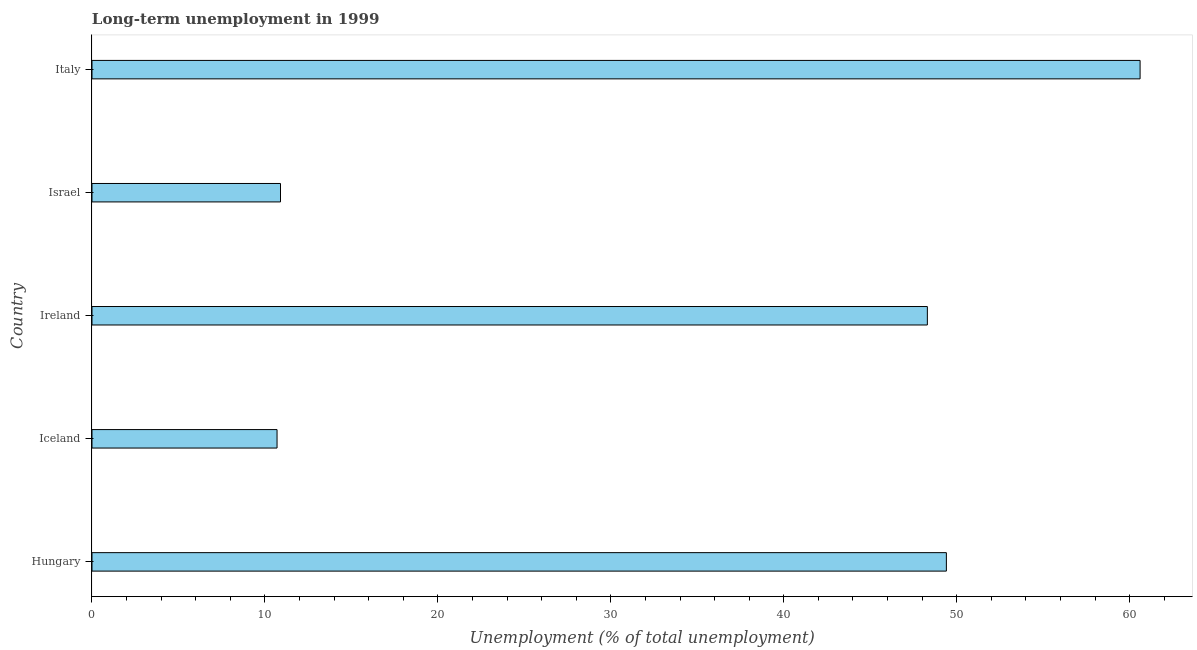Does the graph contain any zero values?
Offer a very short reply. No. Does the graph contain grids?
Keep it short and to the point. No. What is the title of the graph?
Your answer should be very brief. Long-term unemployment in 1999. What is the label or title of the X-axis?
Offer a terse response. Unemployment (% of total unemployment). What is the label or title of the Y-axis?
Make the answer very short. Country. What is the long-term unemployment in Italy?
Ensure brevity in your answer.  60.6. Across all countries, what is the maximum long-term unemployment?
Make the answer very short. 60.6. Across all countries, what is the minimum long-term unemployment?
Offer a very short reply. 10.7. In which country was the long-term unemployment maximum?
Your answer should be very brief. Italy. In which country was the long-term unemployment minimum?
Your response must be concise. Iceland. What is the sum of the long-term unemployment?
Your response must be concise. 179.9. What is the difference between the long-term unemployment in Hungary and Ireland?
Offer a very short reply. 1.1. What is the average long-term unemployment per country?
Make the answer very short. 35.98. What is the median long-term unemployment?
Offer a terse response. 48.3. Is the long-term unemployment in Iceland less than that in Ireland?
Your answer should be compact. Yes. Is the difference between the long-term unemployment in Iceland and Israel greater than the difference between any two countries?
Your answer should be very brief. No. Is the sum of the long-term unemployment in Iceland and Israel greater than the maximum long-term unemployment across all countries?
Keep it short and to the point. No. What is the difference between the highest and the lowest long-term unemployment?
Make the answer very short. 49.9. In how many countries, is the long-term unemployment greater than the average long-term unemployment taken over all countries?
Make the answer very short. 3. How many bars are there?
Give a very brief answer. 5. Are all the bars in the graph horizontal?
Your answer should be compact. Yes. How many countries are there in the graph?
Your response must be concise. 5. Are the values on the major ticks of X-axis written in scientific E-notation?
Provide a short and direct response. No. What is the Unemployment (% of total unemployment) in Hungary?
Make the answer very short. 49.4. What is the Unemployment (% of total unemployment) of Iceland?
Your answer should be very brief. 10.7. What is the Unemployment (% of total unemployment) in Ireland?
Provide a short and direct response. 48.3. What is the Unemployment (% of total unemployment) of Israel?
Ensure brevity in your answer.  10.9. What is the Unemployment (% of total unemployment) in Italy?
Keep it short and to the point. 60.6. What is the difference between the Unemployment (% of total unemployment) in Hungary and Iceland?
Offer a very short reply. 38.7. What is the difference between the Unemployment (% of total unemployment) in Hungary and Ireland?
Provide a succinct answer. 1.1. What is the difference between the Unemployment (% of total unemployment) in Hungary and Israel?
Ensure brevity in your answer.  38.5. What is the difference between the Unemployment (% of total unemployment) in Iceland and Ireland?
Your answer should be compact. -37.6. What is the difference between the Unemployment (% of total unemployment) in Iceland and Israel?
Provide a short and direct response. -0.2. What is the difference between the Unemployment (% of total unemployment) in Iceland and Italy?
Your answer should be compact. -49.9. What is the difference between the Unemployment (% of total unemployment) in Ireland and Israel?
Your response must be concise. 37.4. What is the difference between the Unemployment (% of total unemployment) in Ireland and Italy?
Give a very brief answer. -12.3. What is the difference between the Unemployment (% of total unemployment) in Israel and Italy?
Offer a terse response. -49.7. What is the ratio of the Unemployment (% of total unemployment) in Hungary to that in Iceland?
Offer a terse response. 4.62. What is the ratio of the Unemployment (% of total unemployment) in Hungary to that in Ireland?
Provide a succinct answer. 1.02. What is the ratio of the Unemployment (% of total unemployment) in Hungary to that in Israel?
Ensure brevity in your answer.  4.53. What is the ratio of the Unemployment (% of total unemployment) in Hungary to that in Italy?
Provide a succinct answer. 0.81. What is the ratio of the Unemployment (% of total unemployment) in Iceland to that in Ireland?
Provide a short and direct response. 0.22. What is the ratio of the Unemployment (% of total unemployment) in Iceland to that in Israel?
Provide a succinct answer. 0.98. What is the ratio of the Unemployment (% of total unemployment) in Iceland to that in Italy?
Offer a terse response. 0.18. What is the ratio of the Unemployment (% of total unemployment) in Ireland to that in Israel?
Ensure brevity in your answer.  4.43. What is the ratio of the Unemployment (% of total unemployment) in Ireland to that in Italy?
Your answer should be very brief. 0.8. What is the ratio of the Unemployment (% of total unemployment) in Israel to that in Italy?
Give a very brief answer. 0.18. 